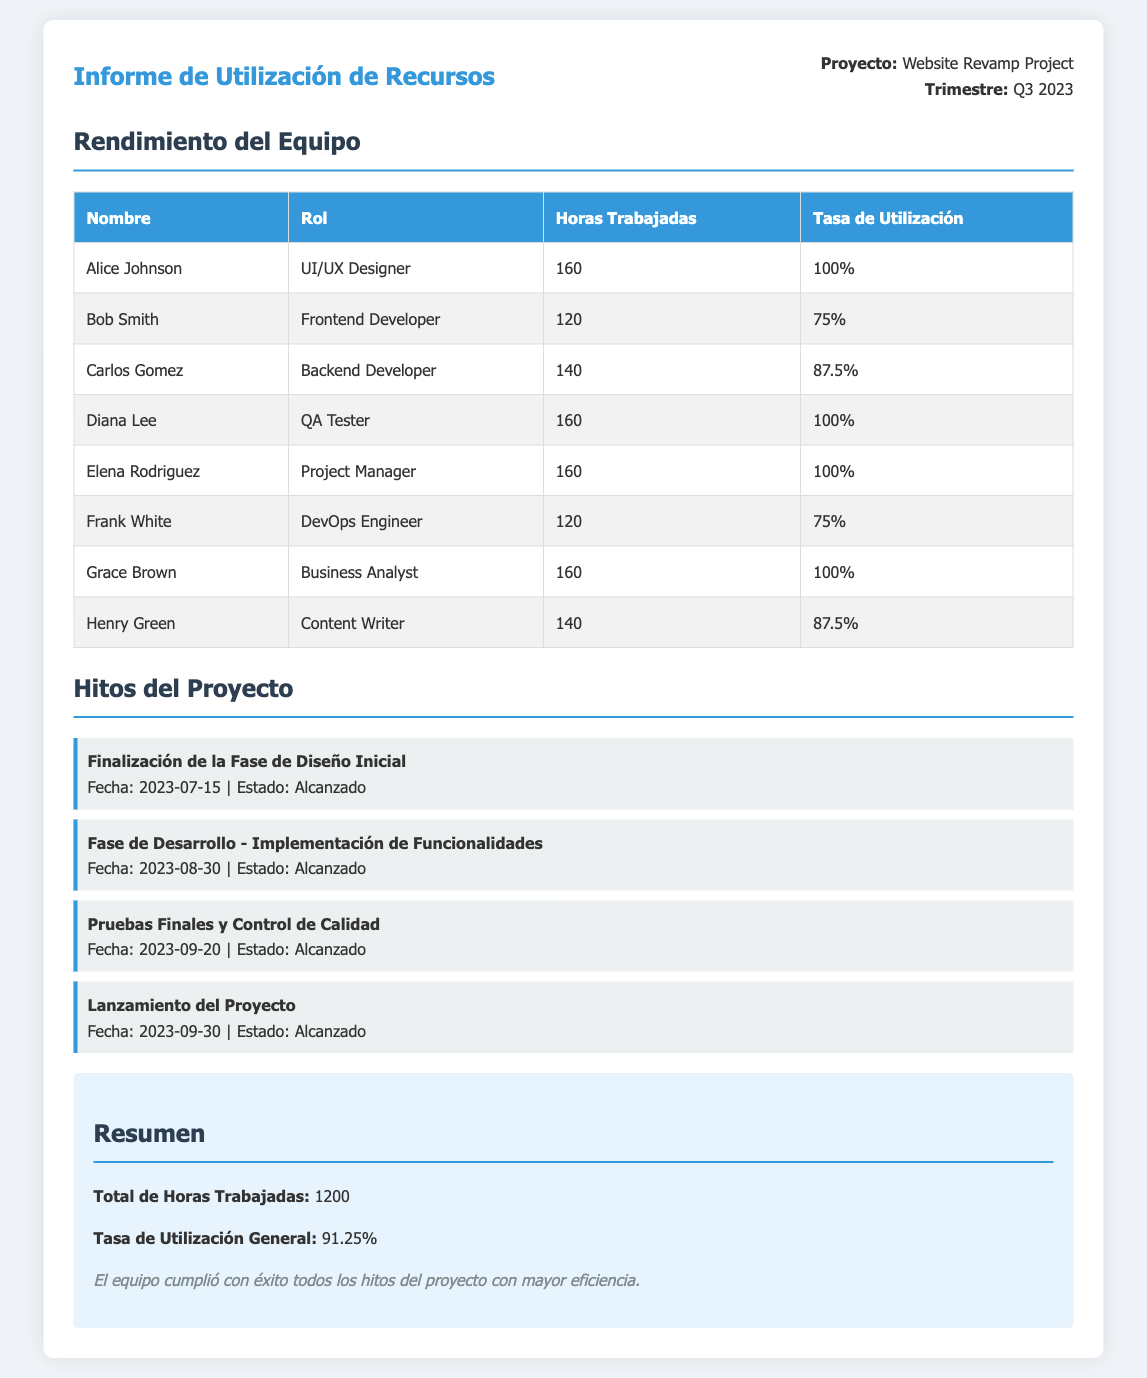¿Cuántas horas trabajó Diana Lee? Diana Lee trabajó un total de 160 horas en el proyecto, según la tabla del rendimiento del equipo.
Answer: 160 ¿Cuál es la tasa de utilización general del equipo? La tasa de utilización general del equipo se encuentra en la sección de resumen y es del 91.25%.
Answer: 91.25% ¿Cuál fue la fecha de finalización de la fase de diseño inicial? La fecha de finalización de la fase de diseño inicial se menciona en los hitos del proyecto, y fue el 15 de julio de 2023.
Answer: 2023-07-15 ¿Quiénes alcanzaron una tasa de utilización del 100%? En la tabla de rendimiento del equipo, los que alcanzaron una tasa de utilización del 100% son Alice Johnson, Diana Lee, y Grace Brown.
Answer: Alice Johnson, Diana Lee, Grace Brown ¿Cuántos hitos del proyecto se han alcanzado? En la sección de hitos del proyecto, se enumeran cuatro hitos que han sido alcanzados.
Answer: 4 ¿Cuál fue el rol de Carlos Gomez en el proyecto? Según la tabla del rendimiento del equipo, Carlos Gomez tuvo el rol de Backend Developer.
Answer: Backend Developer ¿Cuál es el total de horas trabajadas por el equipo? El total de horas trabajadas por el equipo se menciona en el resumen y es de 1200 horas.
Answer: 1200 ¿Qué hitos se lograron en agosto? El hito alcanzado en agosto según la sección de hitos del proyecto es la fase de desarrollo - implementación de funcionalidades, que se completó el 30 de agosto de 2023.
Answer: Fase de Desarrollo - Implementación de Funcionalidades ¿Cuál es el nombre del proyecto? En el documento se menciona que el nombre del proyecto es "Website Revamp Project".
Answer: Website Revamp Project 